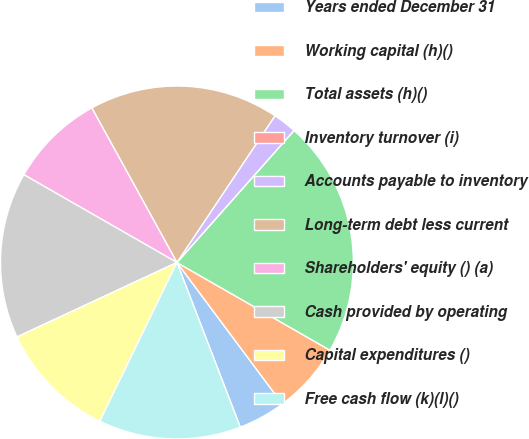Convert chart. <chart><loc_0><loc_0><loc_500><loc_500><pie_chart><fcel>Years ended December 31<fcel>Working capital (h)()<fcel>Total assets (h)()<fcel>Inventory turnover (i)<fcel>Accounts payable to inventory<fcel>Long-term debt less current<fcel>Shareholders' equity () (a)<fcel>Cash provided by operating<fcel>Capital expenditures ()<fcel>Free cash flow (k)(l)()<nl><fcel>4.35%<fcel>6.52%<fcel>21.74%<fcel>0.0%<fcel>2.17%<fcel>17.39%<fcel>8.7%<fcel>15.22%<fcel>10.87%<fcel>13.04%<nl></chart> 